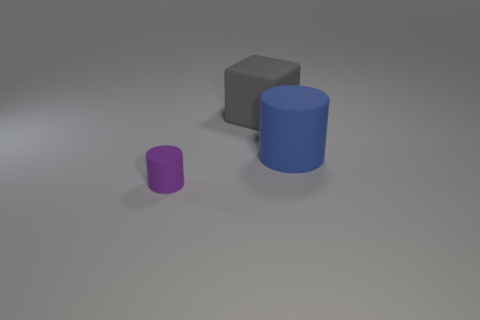What size is the matte thing that is both behind the purple cylinder and to the left of the big cylinder?
Make the answer very short. Large. What number of gray matte cubes are on the left side of the large cylinder?
Provide a succinct answer. 1. There is a rubber cylinder on the right side of the thing on the left side of the large gray block; are there any large rubber cylinders to the right of it?
Your response must be concise. No. What number of rubber cylinders have the same size as the matte cube?
Provide a succinct answer. 1. What material is the object that is to the right of the object that is behind the large cylinder?
Keep it short and to the point. Rubber. What is the shape of the object that is left of the large object behind the matte cylinder that is behind the purple object?
Keep it short and to the point. Cylinder. Is the shape of the small matte thing that is in front of the blue object the same as the big object that is on the right side of the big rubber block?
Offer a very short reply. Yes. What number of other things are made of the same material as the large gray thing?
Give a very brief answer. 2. What is the shape of the large blue thing that is the same material as the small thing?
Provide a succinct answer. Cylinder. Does the purple matte cylinder have the same size as the gray rubber cube?
Offer a terse response. No. 